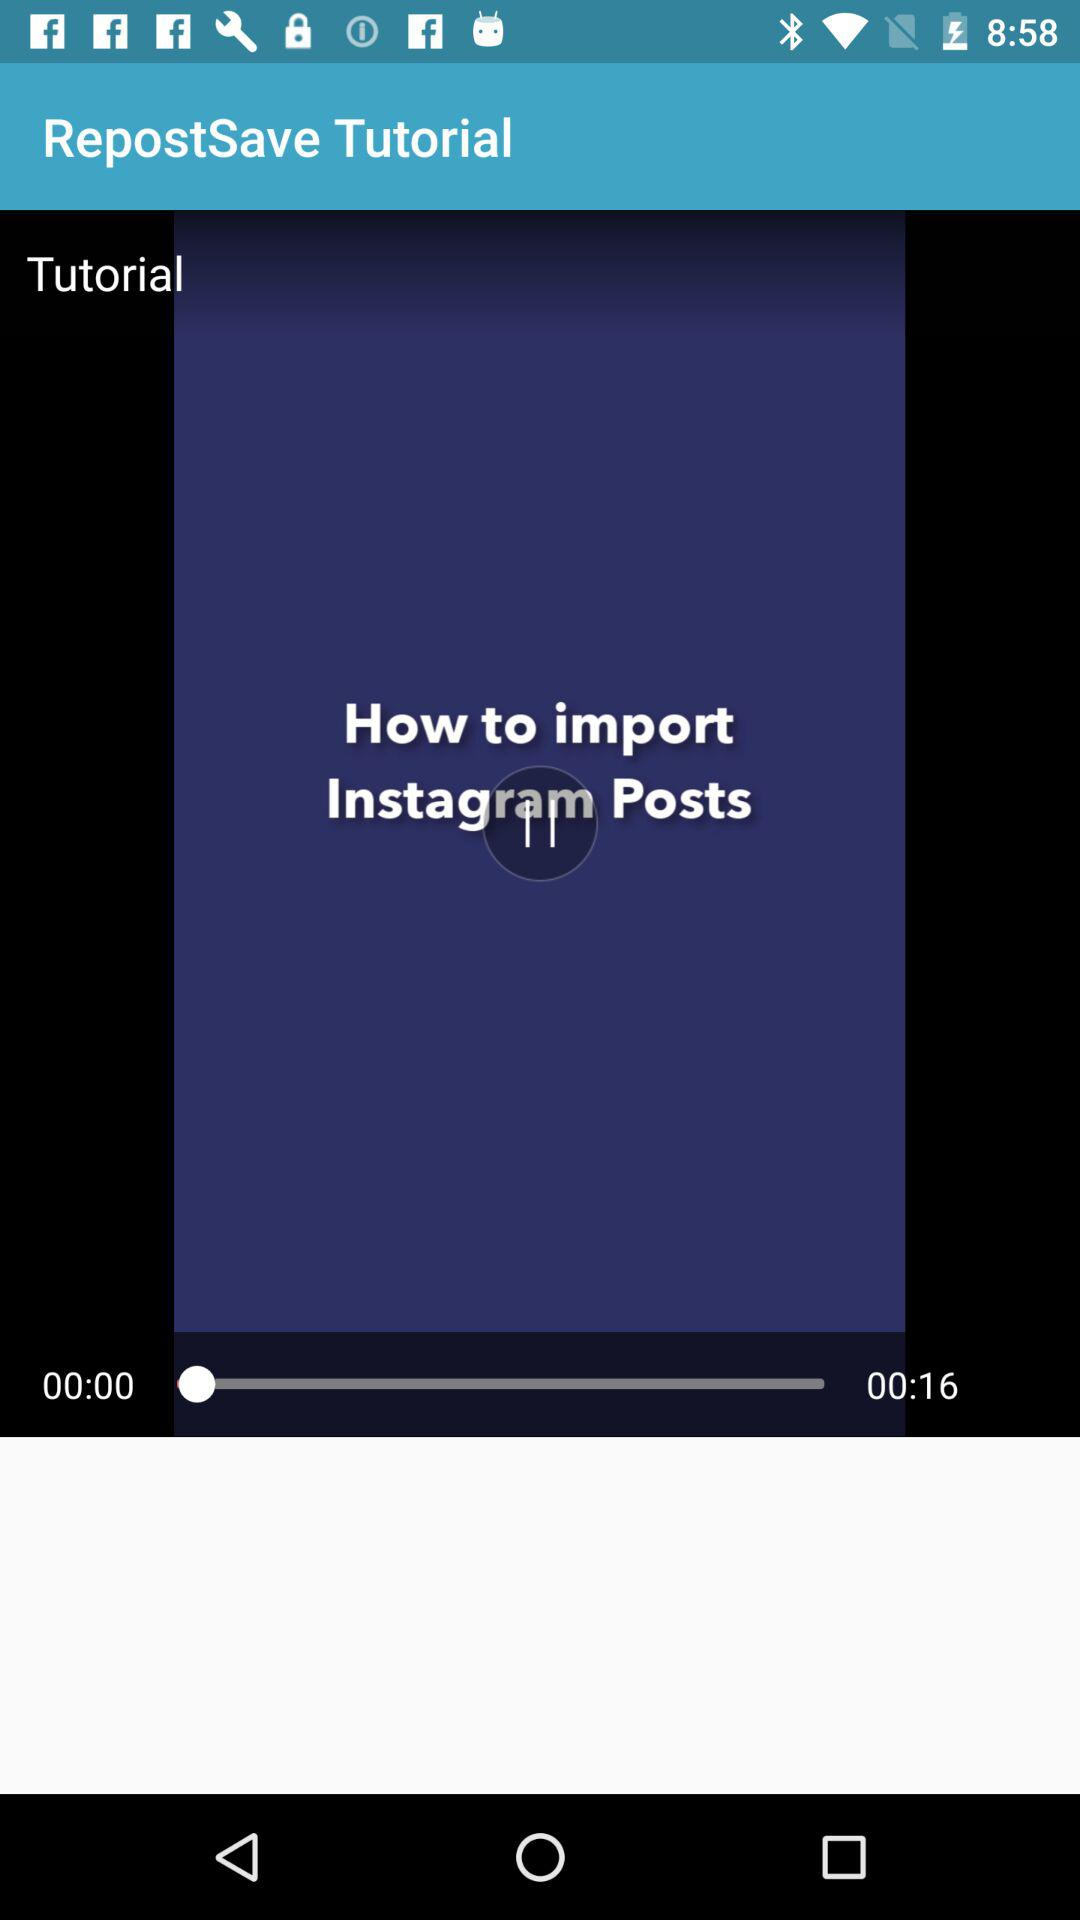How many more seconds are left in the video than have already passed?
Answer the question using a single word or phrase. 16 